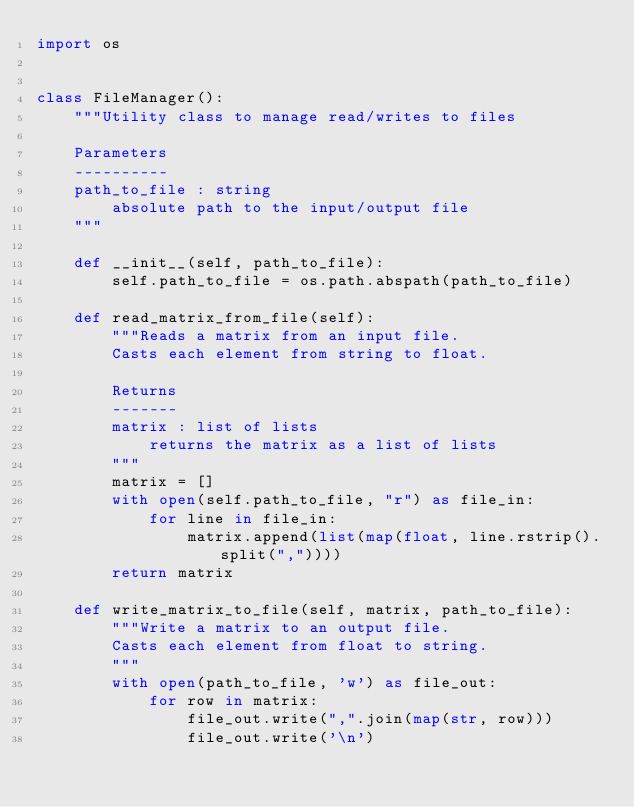<code> <loc_0><loc_0><loc_500><loc_500><_Python_>import os


class FileManager():
    """Utility class to manage read/writes to files

    Parameters
    ----------
    path_to_file : string
        absolute path to the input/output file
    """

    def __init__(self, path_to_file):
        self.path_to_file = os.path.abspath(path_to_file)

    def read_matrix_from_file(self):
        """Reads a matrix from an input file.
        Casts each element from string to float.

        Returns
        -------
        matrix : list of lists
            returns the matrix as a list of lists
        """
        matrix = []
        with open(self.path_to_file, "r") as file_in:
            for line in file_in:
                matrix.append(list(map(float, line.rstrip().split(","))))
        return matrix

    def write_matrix_to_file(self, matrix, path_to_file):
        """Write a matrix to an output file.
        Casts each element from float to string.
        """
        with open(path_to_file, 'w') as file_out:
            for row in matrix:
                file_out.write(",".join(map(str, row)))
                file_out.write('\n')
</code> 